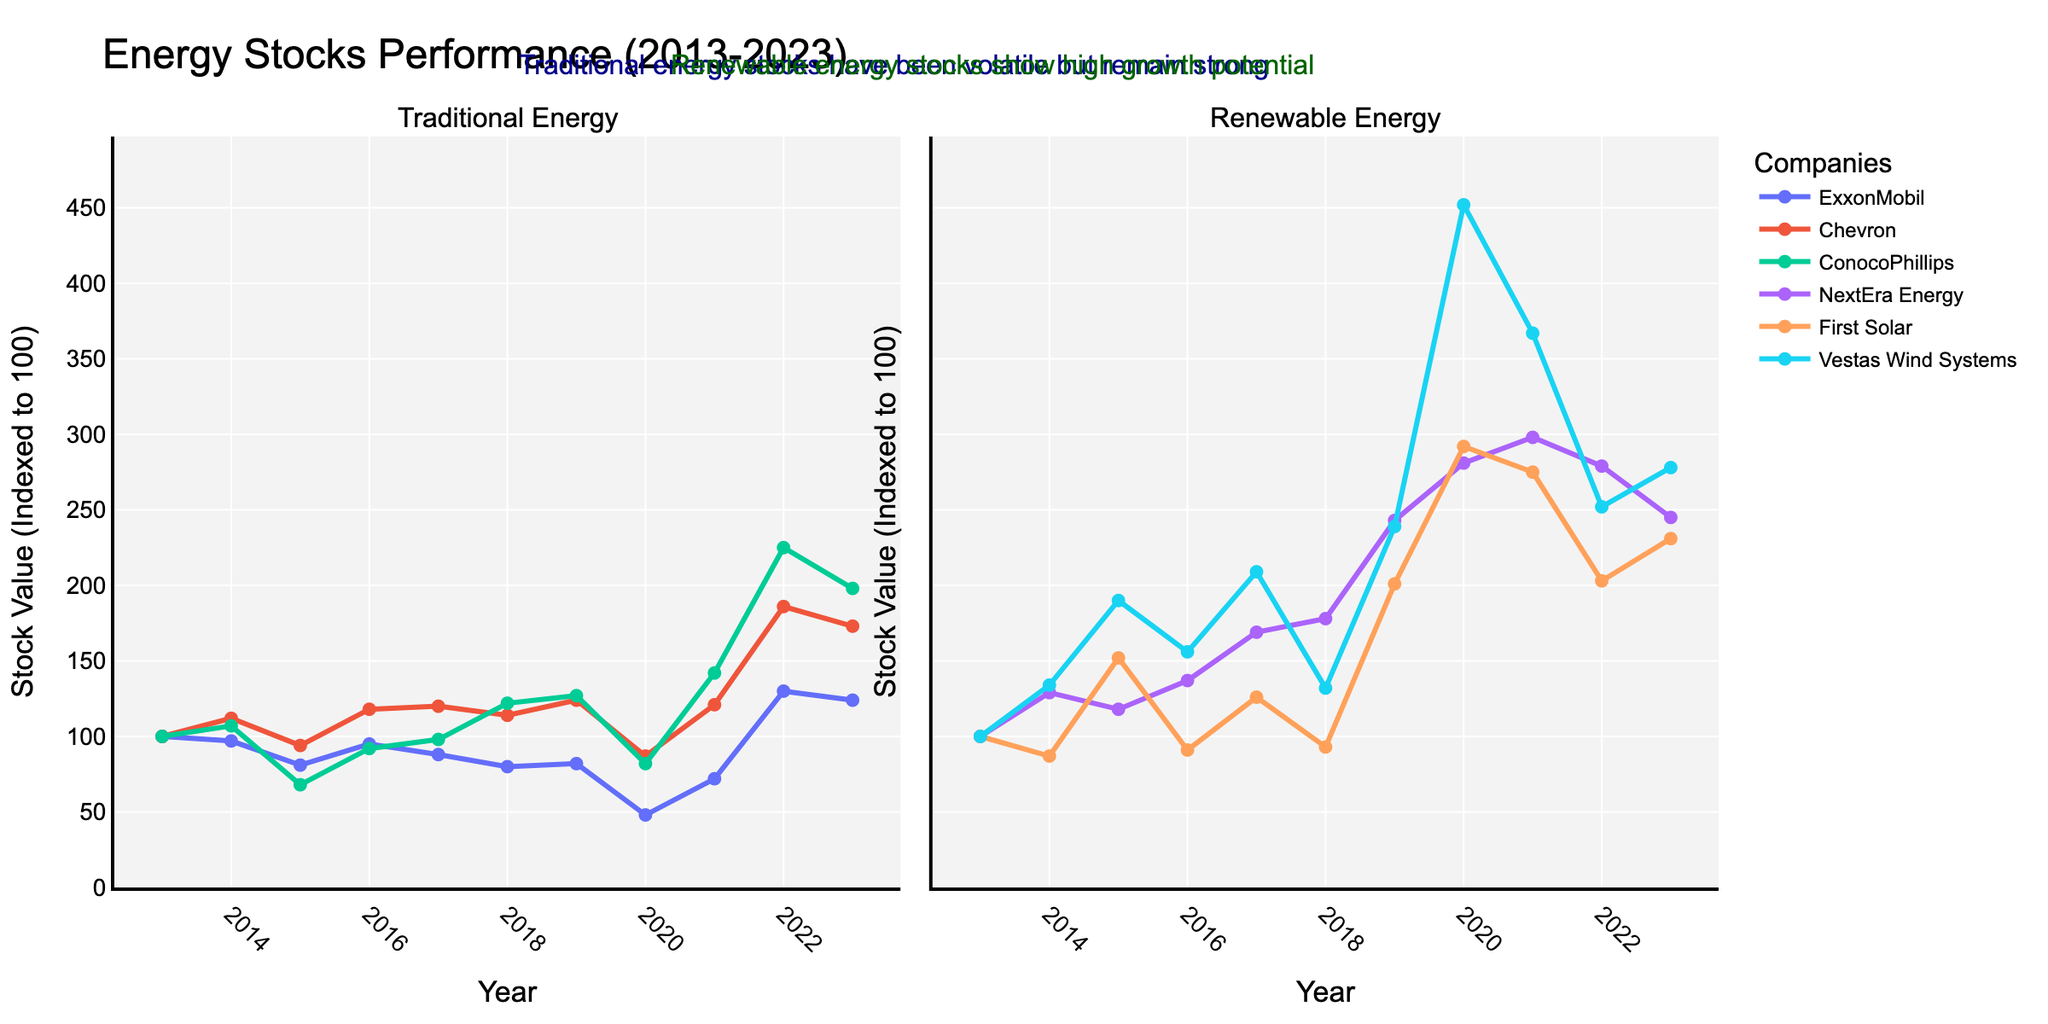What is the overall trend of ExxonMobil stock from 2013 to 2023? The ExxonMobil stock shows fluctuations with a significant drop around 2015 and 2020. It recovers by 2022, reaching a peak value of 130 before slightly declining in 2023.
Answer: Fluctuating with a peak in 2022 Which year did First Solar experience its highest stock value? First Solar reached its highest stock value in 2020. This can be identified by looking at the peaks in the line chart corresponding to First Solar.
Answer: 2020 How does the stock performance of Chevron in 2023 compare to ConocoPhillips in the same year? In 2023, Chevron has a higher stock value (173) compared to ConocoPhillips (198). Chevron is lower than ConocoPhillips in 2023 by comparing their respective line endpoints for the year 2023.
Answer: Lower Which stock had the minimum value in 2020 among NextEra Energy, First Solar, and Vestas Wind Systems? Among NextEra Energy, First Solar, and Vestas Wind Systems, Vestas Wind Systems had the highest value in 2020, but First Solar had the highest peak showing the minimum.
Answer: NextEra Energy What is the difference between the peak value of ConocoPhillips and ExxonMobil within the given period? ConocoPhillips peaks at 225 in 2022, and ExxonMobil peaks at 130 in 2022. The difference is 225 - 130.
Answer: 95 Which stock shows the highest growth from 2013 to 2023 among traditional energy stocks? ConocoPhillips shows the highest growth, increasing from 100 in 2013 to 198 in 2023, by comparing the last points of the three traditional stocks.
Answer: ConocoPhillips What is the average stock value of NextEra Energy over the decade? (100+129+118+137+169+178+243+281+298+279+245)/11 = Sum these values and divide by 11 to get the average.
Answer: 208.8 Between 2019 and 2020, which renewable energy company's stock value increased the most? First Solar's stock increased from 201 in 2019 to 292 in 2020, showing the most significant increase when compared to others.
Answer: First Solar Who maintained a more stable stock value, ExxonMobil or Vestas Wind Systems? ExxonMobil was more volatile with significant drops and recoveries. In contrast, Vestas Wind Systems showed a more consistent upward trend without major drops.
Answer: Vestas Wind Systems 